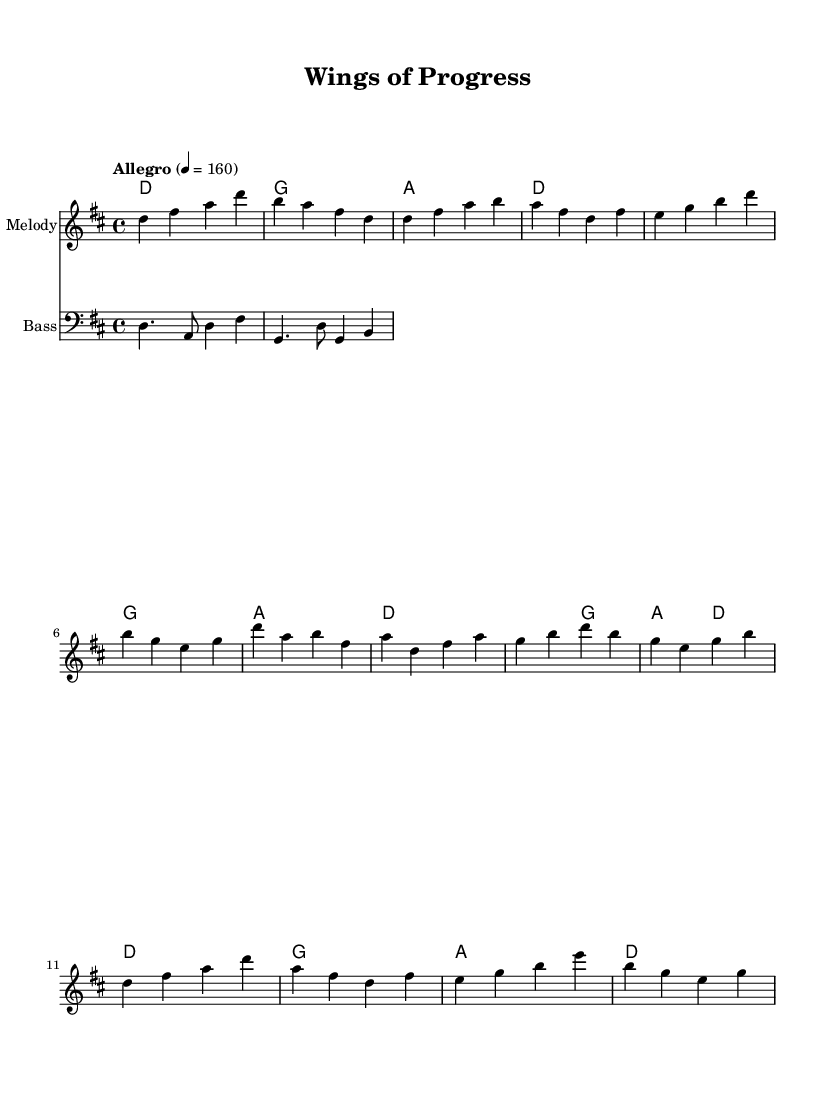What is the key signature of this music? The key signature is D major, which has two sharps: F# and C#.
Answer: D major What is the time signature of this music? The time signature is 4/4, indicating four beats per measure.
Answer: 4/4 What is the tempo marking for this piece? The tempo marking is "Allegro," indicating a fast-paced and lively performance.
Answer: Allegro How many measures are in the verse section? The verse section consists of 4 measures, as indicated by the repeated sequence of notes.
Answer: 4 measures What is the lowest note in the melody? The lowest note in the melody is D, which appears frequently throughout the piece.
Answer: D Which section features a repeated rhythmic pattern unique to Latin music? The Montuno section features a repeated rhythmic pattern that is characteristic of Latin music styles.
Answer: Montuno How many chords are in the chorus? There are two chords in the chorus, as shown in the chord progression in that section.
Answer: 2 chords 